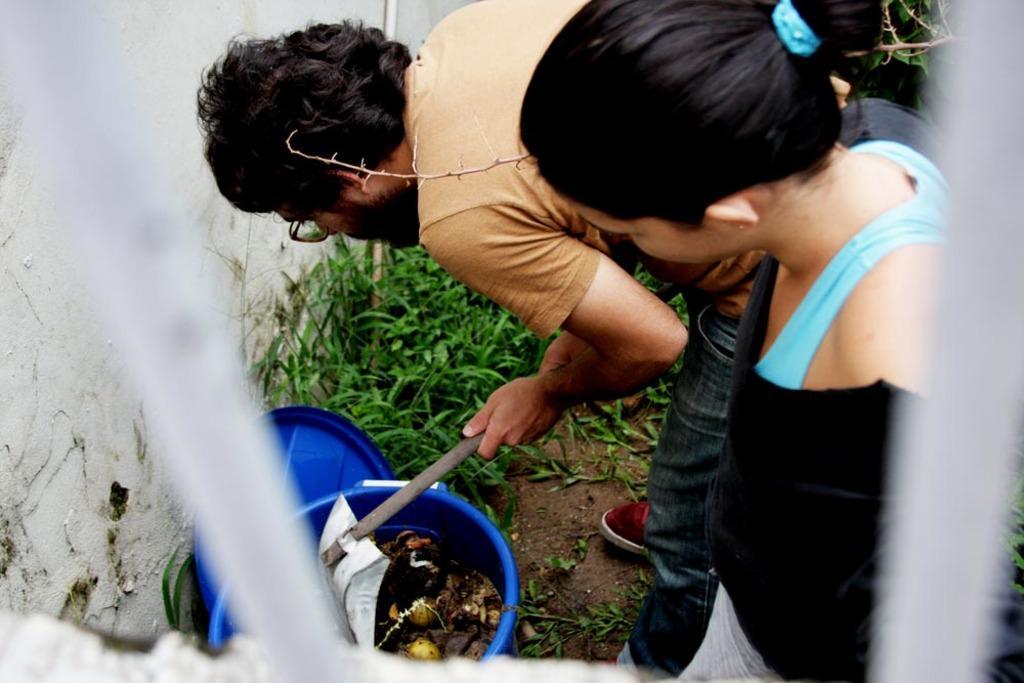How would you summarize this image in a sentence or two? In the picture we can see a man and a woman are standing and man is bending and searching something in the blue color dustbin and beside it, we can see the grass and behind it we can see a part of the wall. 